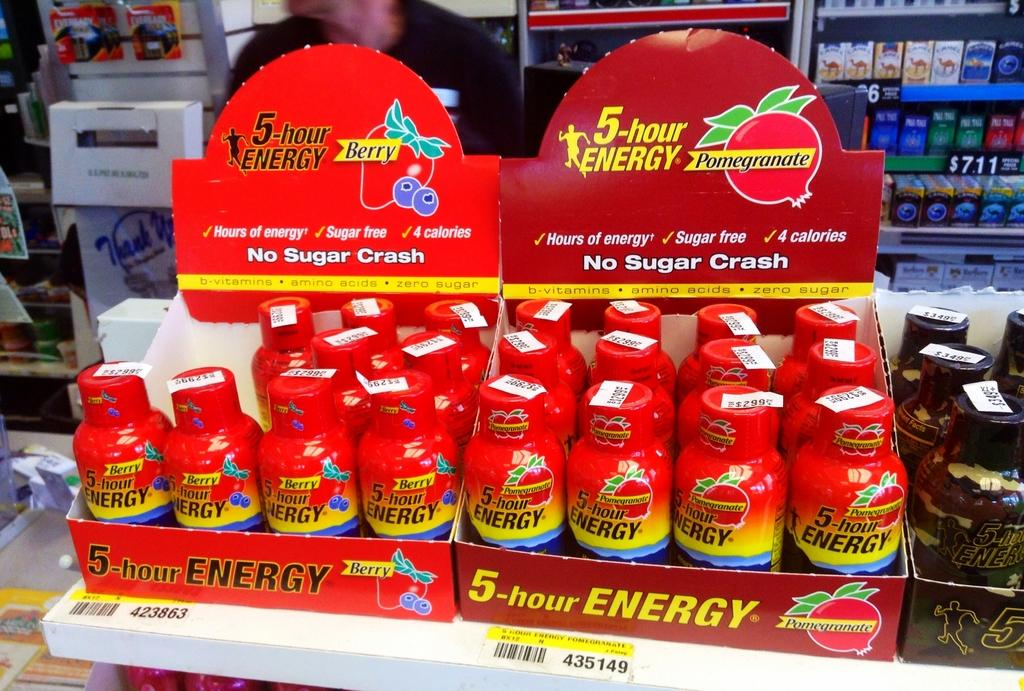<image>
Offer a succinct explanation of the picture presented. A display of small bottles that are 5 hour energy drinks. 